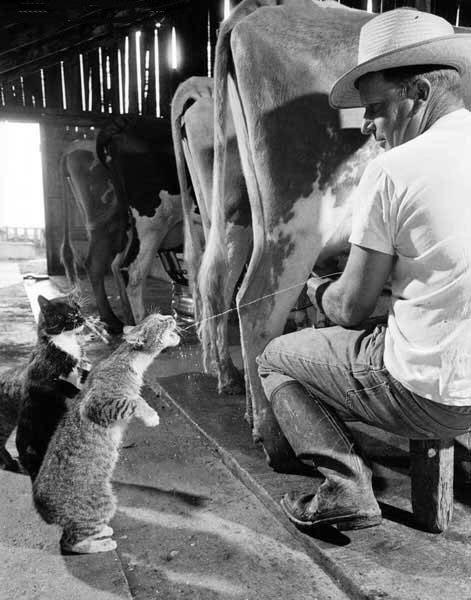Describe the objects in this image and their specific colors. I can see people in black, lightgray, darkgray, and gray tones, cow in black, darkgray, gray, and lightgray tones, cat in black, gray, darkgray, and lightgray tones, cow in black and gray tones, and cow in black, darkgray, gray, and lightgray tones in this image. 